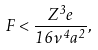Convert formula to latex. <formula><loc_0><loc_0><loc_500><loc_500>F < \frac { Z ^ { 3 } e } { 1 6 \nu ^ { 4 } a ^ { 2 } } ,</formula> 